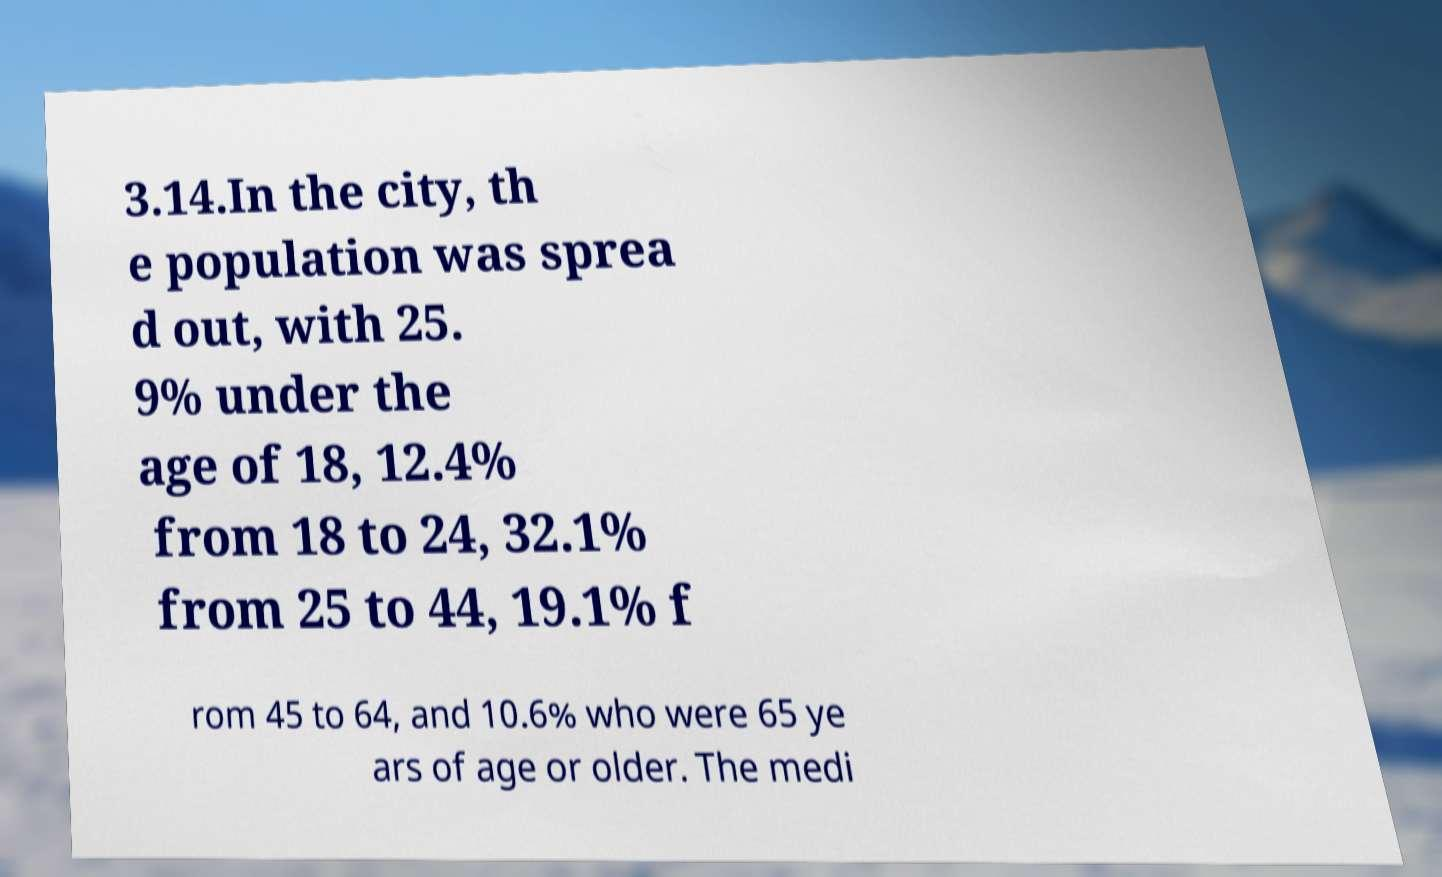Please identify and transcribe the text found in this image. 3.14.In the city, th e population was sprea d out, with 25. 9% under the age of 18, 12.4% from 18 to 24, 32.1% from 25 to 44, 19.1% f rom 45 to 64, and 10.6% who were 65 ye ars of age or older. The medi 